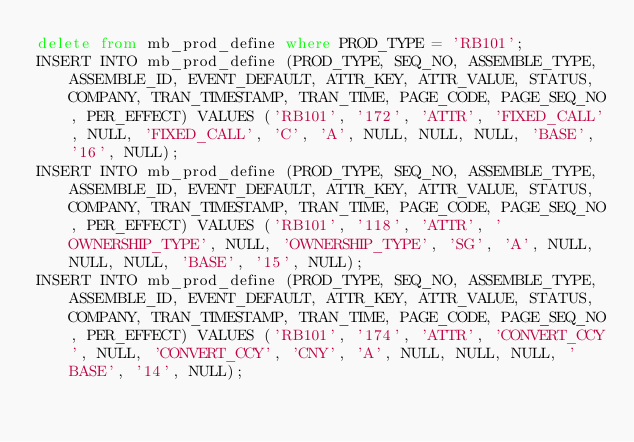<code> <loc_0><loc_0><loc_500><loc_500><_SQL_>delete from mb_prod_define where PROD_TYPE = 'RB101';
INSERT INTO mb_prod_define (PROD_TYPE, SEQ_NO, ASSEMBLE_TYPE, ASSEMBLE_ID, EVENT_DEFAULT, ATTR_KEY, ATTR_VALUE, STATUS, COMPANY, TRAN_TIMESTAMP, TRAN_TIME, PAGE_CODE, PAGE_SEQ_NO, PER_EFFECT) VALUES ('RB101', '172', 'ATTR', 'FIXED_CALL', NULL, 'FIXED_CALL', 'C', 'A', NULL, NULL, NULL, 'BASE', '16', NULL);
INSERT INTO mb_prod_define (PROD_TYPE, SEQ_NO, ASSEMBLE_TYPE, ASSEMBLE_ID, EVENT_DEFAULT, ATTR_KEY, ATTR_VALUE, STATUS, COMPANY, TRAN_TIMESTAMP, TRAN_TIME, PAGE_CODE, PAGE_SEQ_NO, PER_EFFECT) VALUES ('RB101', '118', 'ATTR', 'OWNERSHIP_TYPE', NULL, 'OWNERSHIP_TYPE', 'SG', 'A', NULL, NULL, NULL, 'BASE', '15', NULL);
INSERT INTO mb_prod_define (PROD_TYPE, SEQ_NO, ASSEMBLE_TYPE, ASSEMBLE_ID, EVENT_DEFAULT, ATTR_KEY, ATTR_VALUE, STATUS, COMPANY, TRAN_TIMESTAMP, TRAN_TIME, PAGE_CODE, PAGE_SEQ_NO, PER_EFFECT) VALUES ('RB101', '174', 'ATTR', 'CONVERT_CCY', NULL, 'CONVERT_CCY', 'CNY', 'A', NULL, NULL, NULL, 'BASE', '14', NULL);</code> 